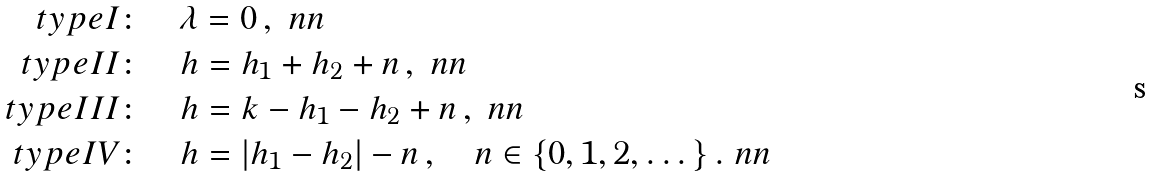<formula> <loc_0><loc_0><loc_500><loc_500>t y p e I \colon \quad & \lambda = 0 \, , \ n n \\ t y p e I I \colon \quad & h = h _ { 1 } + h _ { 2 } + n \, , \ n n \\ t y p e I I I \colon \quad & h = k - h _ { 1 } - h _ { 2 } + n \, , \ n n \\ t y p e I V \colon \quad & h = | h _ { 1 } - h _ { 2 } | - n \, , \quad n \in \{ 0 , 1 , 2 , \dots \} \, . \ n n</formula> 